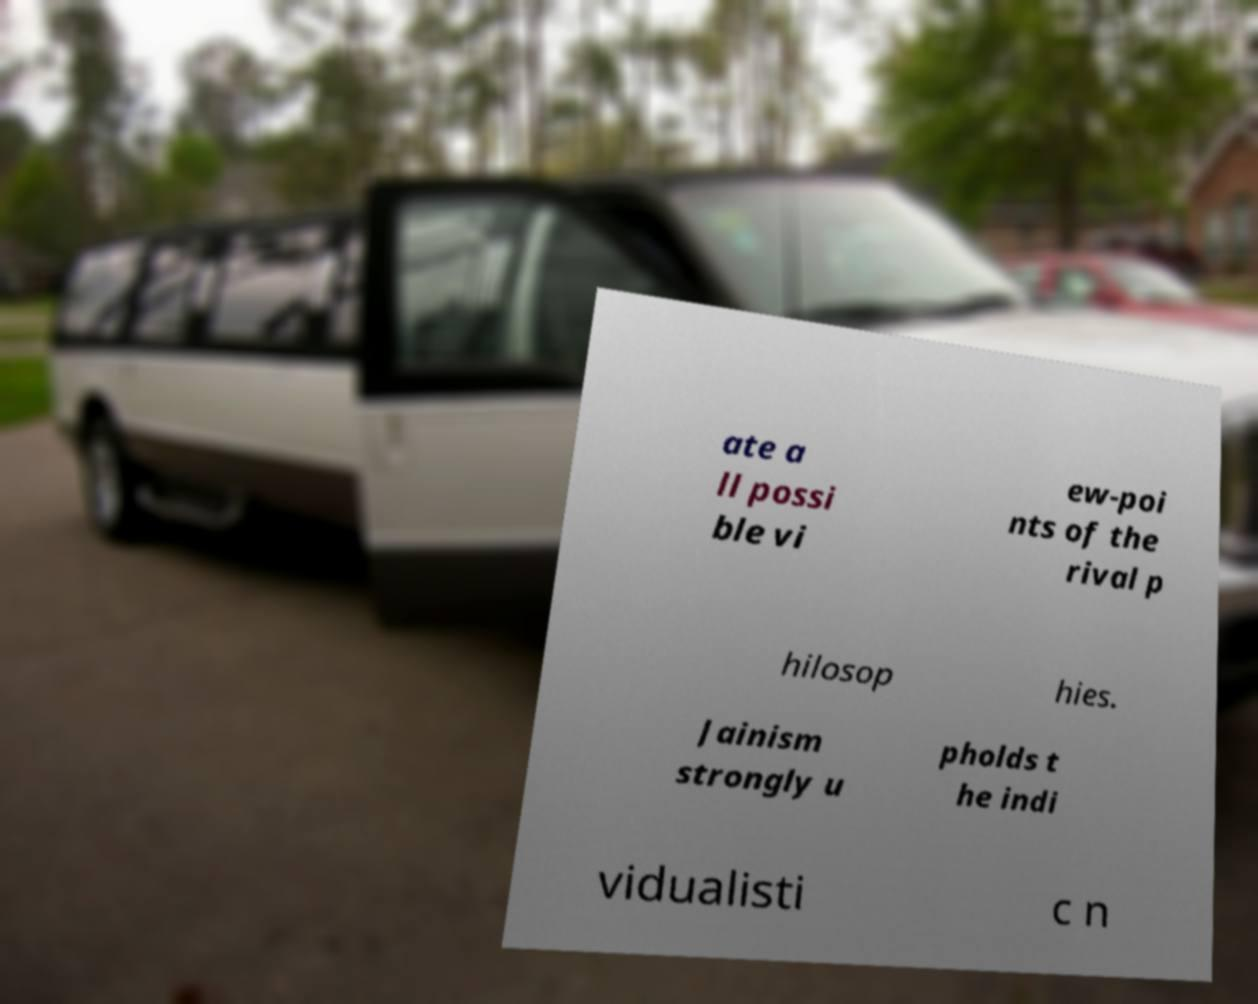I need the written content from this picture converted into text. Can you do that? ate a ll possi ble vi ew-poi nts of the rival p hilosop hies. Jainism strongly u pholds t he indi vidualisti c n 